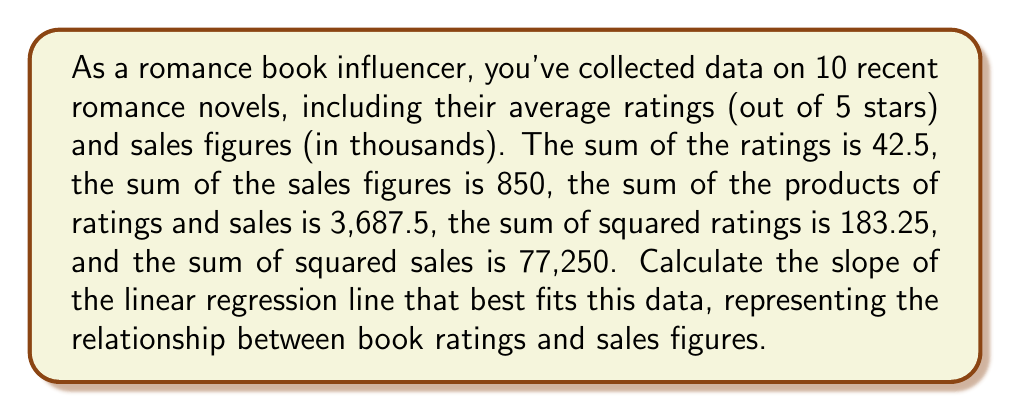Give your solution to this math problem. To find the slope of the linear regression line, we'll use the formula:

$$ m = \frac{n\sum xy - \sum x \sum y}{n\sum x^2 - (\sum x)^2} $$

Where:
$n$ = number of data points (10)
$x$ = book ratings
$y$ = sales figures (in thousands)

Given:
$\sum x = 42.5$
$\sum y = 850$
$\sum xy = 3,687.5$
$\sum x^2 = 183.25$

Step 1: Calculate $(\sum x)^2$
$(\sum x)^2 = 42.5^2 = 1,806.25$

Step 2: Substitute values into the slope formula
$$ m = \frac{10(3,687.5) - 42.5(850)}{10(183.25) - 1,806.25} $$

Step 3: Simplify the numerator and denominator
$$ m = \frac{36,875 - 36,125}{1,832.5 - 1,806.25} $$

Step 4: Calculate the final result
$$ m = \frac{750}{26.25} = 28.57 $$
Answer: $28.57$ 